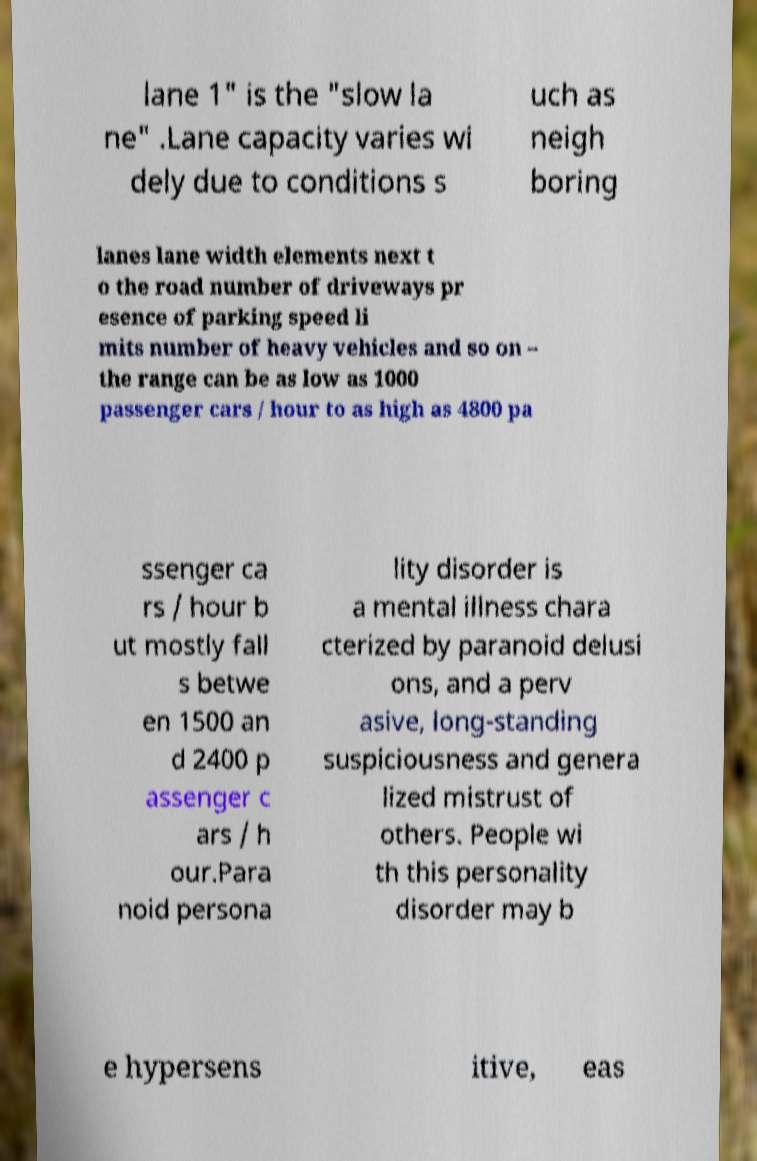I need the written content from this picture converted into text. Can you do that? lane 1" is the "slow la ne" .Lane capacity varies wi dely due to conditions s uch as neigh boring lanes lane width elements next t o the road number of driveways pr esence of parking speed li mits number of heavy vehicles and so on – the range can be as low as 1000 passenger cars / hour to as high as 4800 pa ssenger ca rs / hour b ut mostly fall s betwe en 1500 an d 2400 p assenger c ars / h our.Para noid persona lity disorder is a mental illness chara cterized by paranoid delusi ons, and a perv asive, long-standing suspiciousness and genera lized mistrust of others. People wi th this personality disorder may b e hypersens itive, eas 